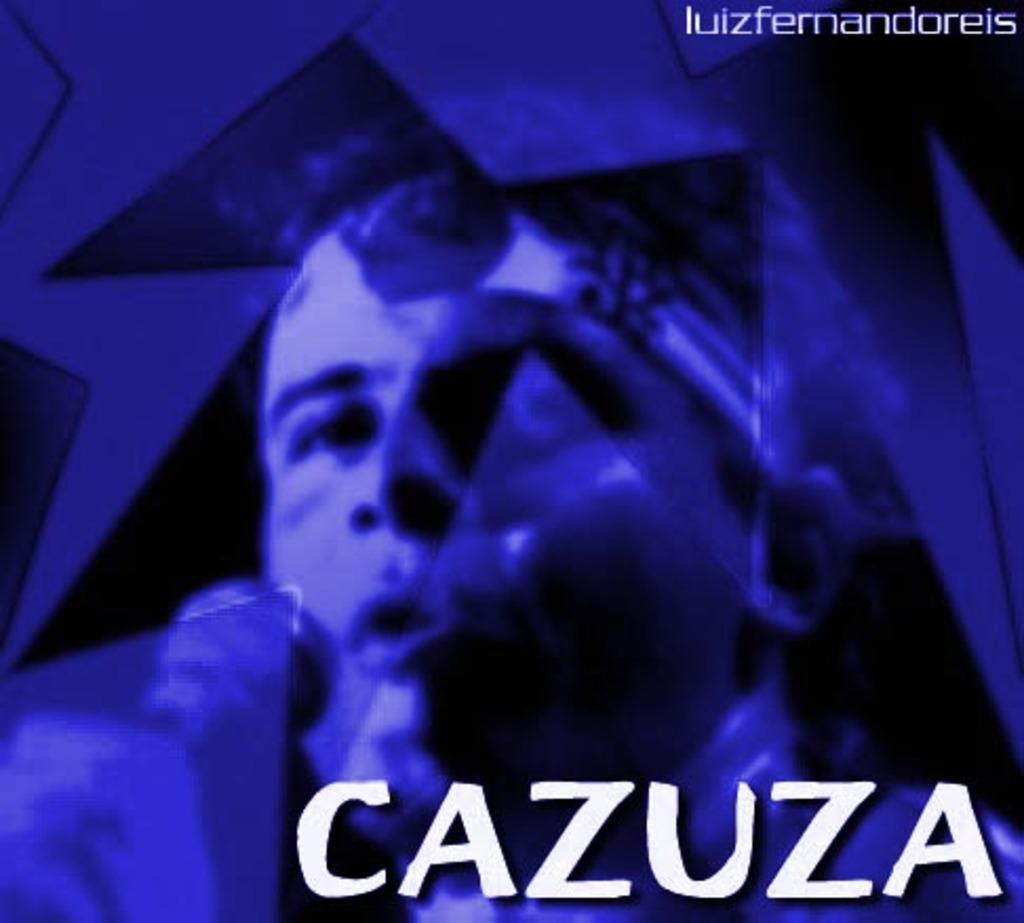Please provide a concise description of this image. This is an edited image, we can see a person is holding a microphone and on the image there are watermarks. 